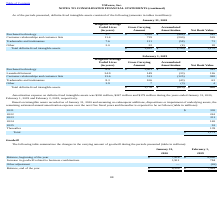From Vmware's financial document, Which years does the table provide information for the changes in the carrying amount of goodwill? The document shows two values: 2020 and 2019. From the document: "February 1, 2019 January 31, 2020..." Also, What was the increase in goodwill related to business combinations in 2019? According to the financial document, 784 (in millions). The relevant text states: "n goodwill related to business combinations 1,911 784..." Also, What was the balance at the end of the year in 2020? According to the financial document, 9,329 (in millions). The relevant text states: "Balance, end of the year $ 9,329 $ 7,418..." Also, can you calculate: What was the change in the Increase in goodwill related to business combinations between 2019 and 2020? Based on the calculation: 1,911-784, the result is 1127 (in millions). This is based on the information: "n goodwill related to business combinations 1,911 784 ease in goodwill related to business combinations 1,911 784..." The key data points involved are: 1,911, 784. Also, can you calculate: What was the change in balance at the beginning of the year between 2019 and 2020? Based on the calculation: 7,418-6,660, the result is 758 (in millions). This is based on the information: "Balance, beginning of the year $ 7,418 $ 6,660 Balance, beginning of the year $ 7,418 $ 6,660..." The key data points involved are: 6,660, 7,418. Also, can you calculate: What was the percentage change in the balance at the end of the year between 2019 and 2020? To answer this question, I need to perform calculations using the financial data. The calculation is: (9,329-7,418)/7,418, which equals 25.76 (percentage). This is based on the information: "Balance, beginning of the year $ 7,418 $ 6,660 Balance, end of the year $ 9,329 $ 7,418..." The key data points involved are: 7,418, 9,329. 